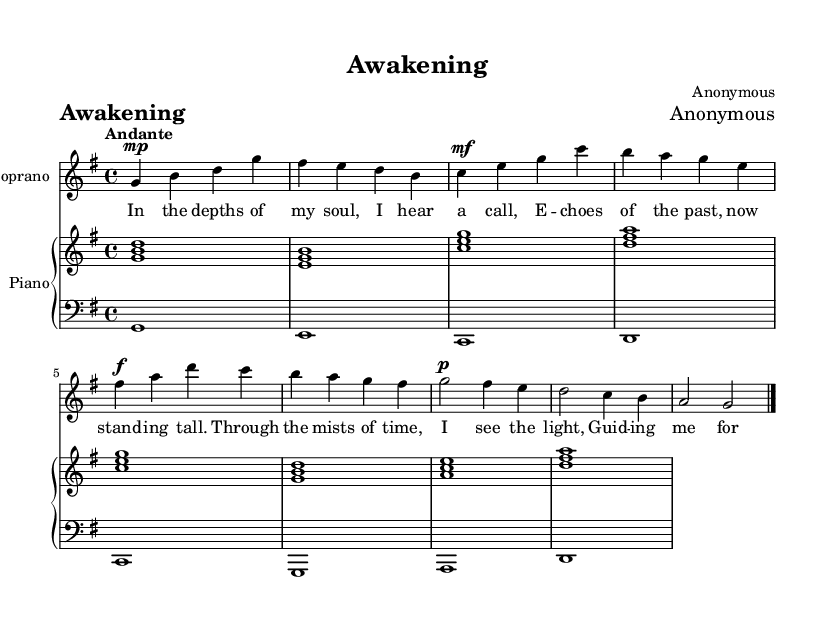What is the key signature of this music? The key signature is G major, which has one sharp (F#). This can be determined from the global music setup indicating "g \major".
Answer: G major What is the time signature of this music? The time signature is 4/4, which indicates that there are four beats in each measure and the quarter note gets one beat. This information appears in the global section as "time 4/4".
Answer: 4/4 What is the tempo marking for this piece? The tempo marking is "Andante", indicating a moderately slow tempo. This is found in the global section with the directive "tempo "Andante"".
Answer: Andante How many measures are in the soprano part? There are a total of 8 measures in the soprano part, which can be counted from the notation section where each measure is separated by a vertical line.
Answer: 8 What is the dynamic marking for the first phrase of the soprano? The dynamic marking for the first phrase of the soprano is "mp", indicating a medium soft volume. This is noted with the marking "g4\mp" in the music.
Answer: mp What is the name given to the primary theme described in this piece? The primary theme of this piece is titled “Awakening”, which is indicated in the header of the sheet music as "title = 'Awakening'".
Answer: Awakening Which instrument is assigned to the right hand in the piano part? The right hand in the piano part has chordal accompaniment, noted as "pianoRH" where it plays melodies consistent with the soprano. This is reflected in the piano staff labeled "right".
Answer: Piano 